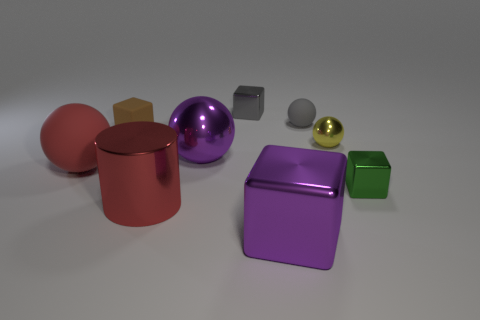Are there more large things right of the small brown matte object than green metallic blocks?
Offer a very short reply. Yes. There is a tiny rubber ball; are there any cubes on the left side of it?
Your response must be concise. Yes. Does the yellow shiny ball have the same size as the gray shiny object?
Ensure brevity in your answer.  Yes. What size is the brown object that is the same shape as the gray shiny object?
Your answer should be very brief. Small. Is there any other thing that is the same size as the gray shiny block?
Make the answer very short. Yes. What is the material of the tiny block that is in front of the purple metal object that is behind the big purple metallic cube?
Give a very brief answer. Metal. Do the yellow metallic thing and the gray metal object have the same shape?
Your answer should be compact. No. How many things are in front of the tiny gray metallic block and behind the small gray matte object?
Give a very brief answer. 0. Is the number of small yellow shiny objects left of the gray sphere the same as the number of metal cylinders behind the cylinder?
Your response must be concise. Yes. There is a purple thing to the left of the large purple metal block; is its size the same as the red object that is in front of the green thing?
Keep it short and to the point. Yes. 